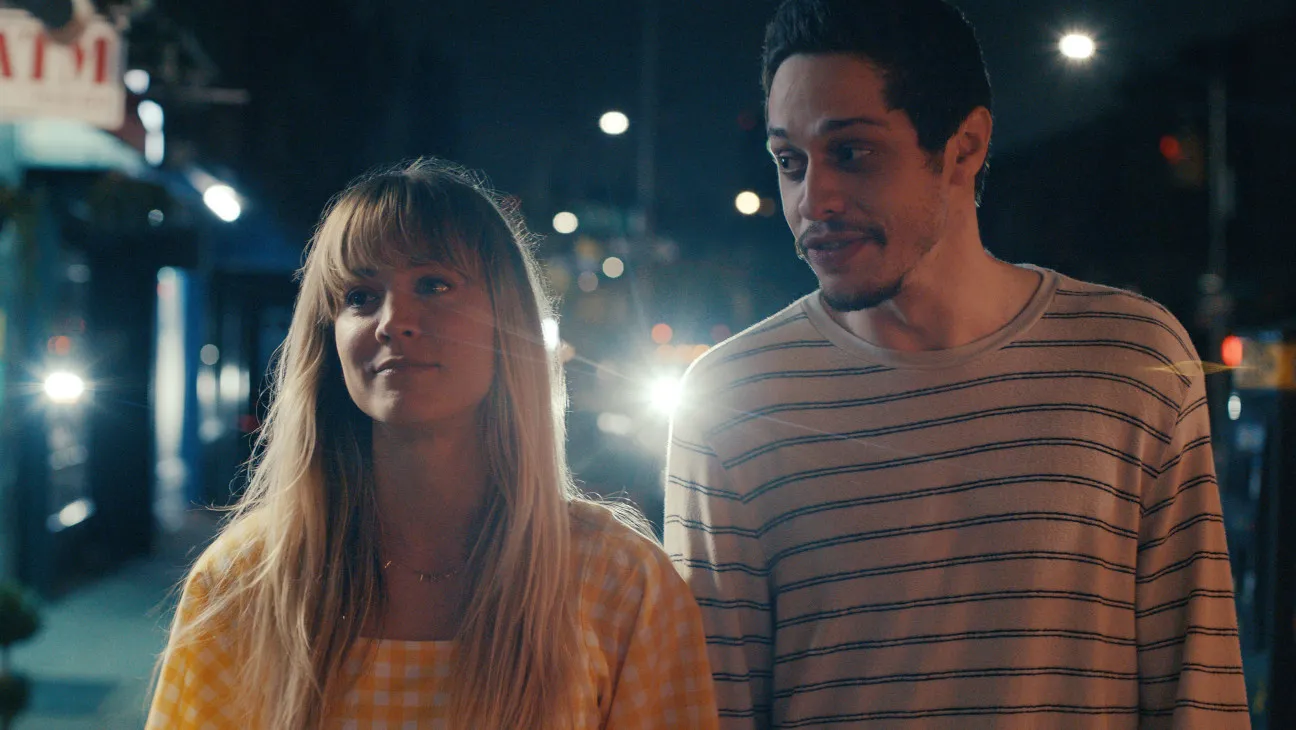What does the lighting reveal about the mood of the scene? The lighting in the image, primarily from streetlights and signage, casts a warm, soft glow on the subjects and their surroundings. This type of lighting often suggests an intimate or serene ambiance, which is enhanced by the nighttime setting. It emphasizes the personal connection or quiet moment occurring between the two individuals against the backdrop of an active urban environment. 